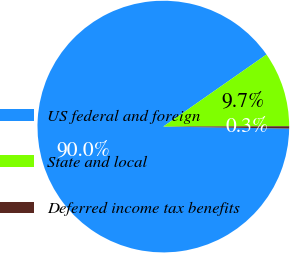<chart> <loc_0><loc_0><loc_500><loc_500><pie_chart><fcel>US federal and foreign<fcel>State and local<fcel>Deferred income tax benefits<nl><fcel>90.04%<fcel>9.66%<fcel>0.3%<nl></chart> 